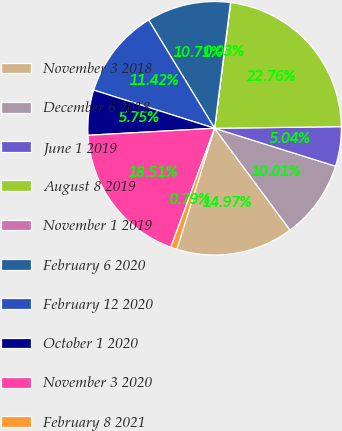<chart> <loc_0><loc_0><loc_500><loc_500><pie_chart><fcel>November 3 2018<fcel>December 6 2018<fcel>June 1 2019<fcel>August 8 2019<fcel>November 1 2019<fcel>February 6 2020<fcel>February 12 2020<fcel>October 1 2020<fcel>November 3 2020<fcel>February 8 2021<nl><fcel>14.97%<fcel>10.01%<fcel>5.04%<fcel>22.76%<fcel>0.03%<fcel>10.71%<fcel>11.42%<fcel>5.75%<fcel>18.51%<fcel>0.79%<nl></chart> 